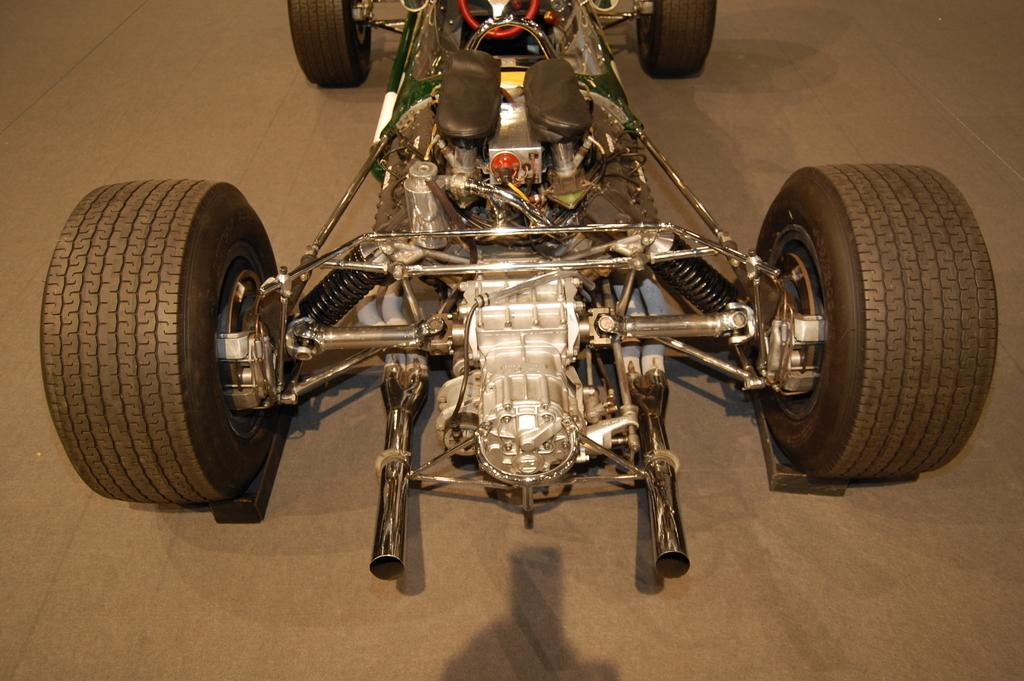What type of vehicle is in the image? The vehicle in the image looks like a go-kart. Can you describe any specific features of the vehicle? The vehicle in the image looks like a go-kart, which typically has a small frame, four wheels, and a seat for the driver. What is visible at the bottom of the image? There is a floor visible at the bottom of the image. What type of bike can be seen glued to the floor in the image? There is no bike present in the image, and the vehicle in the image is a go-kart, not a bike. What type of leaf can be seen falling from the sky in the image? There is no leaf present in the image; the image only features a go-kart and a floor. 